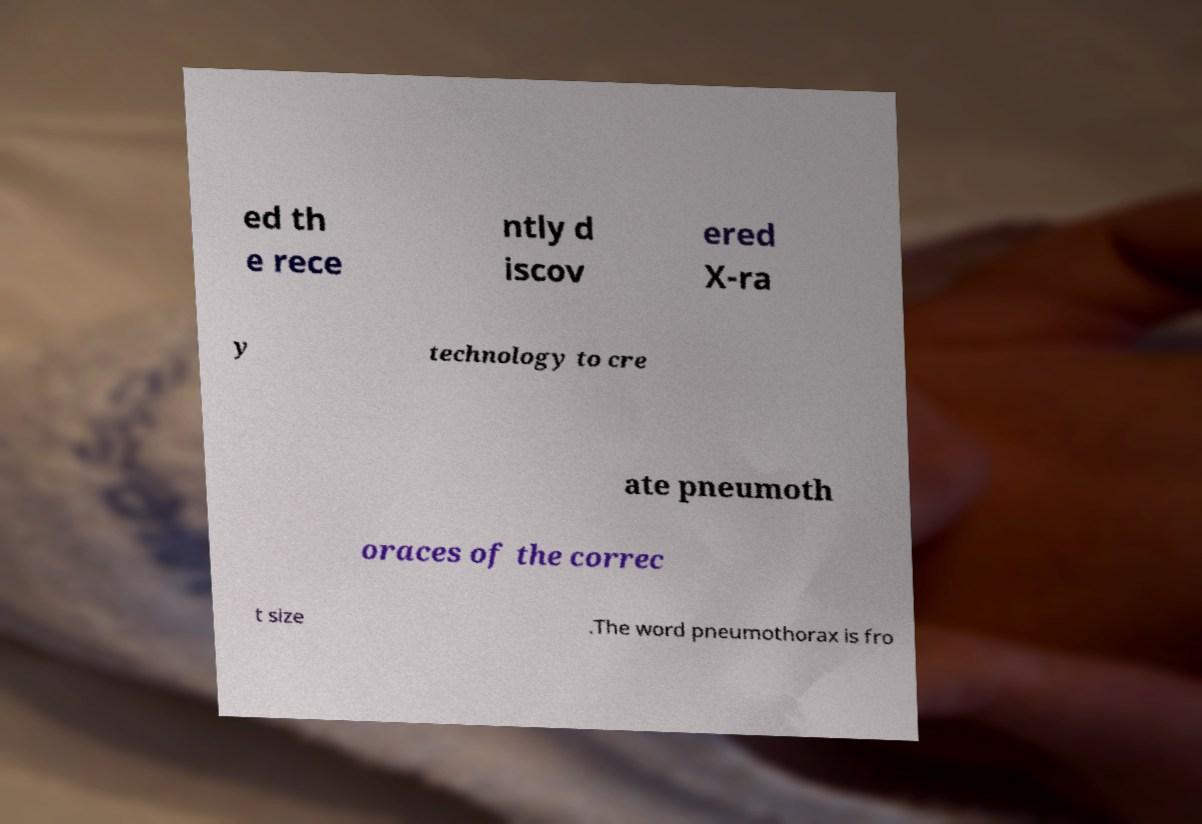Please read and relay the text visible in this image. What does it say? ed th e rece ntly d iscov ered X-ra y technology to cre ate pneumoth oraces of the correc t size .The word pneumothorax is fro 